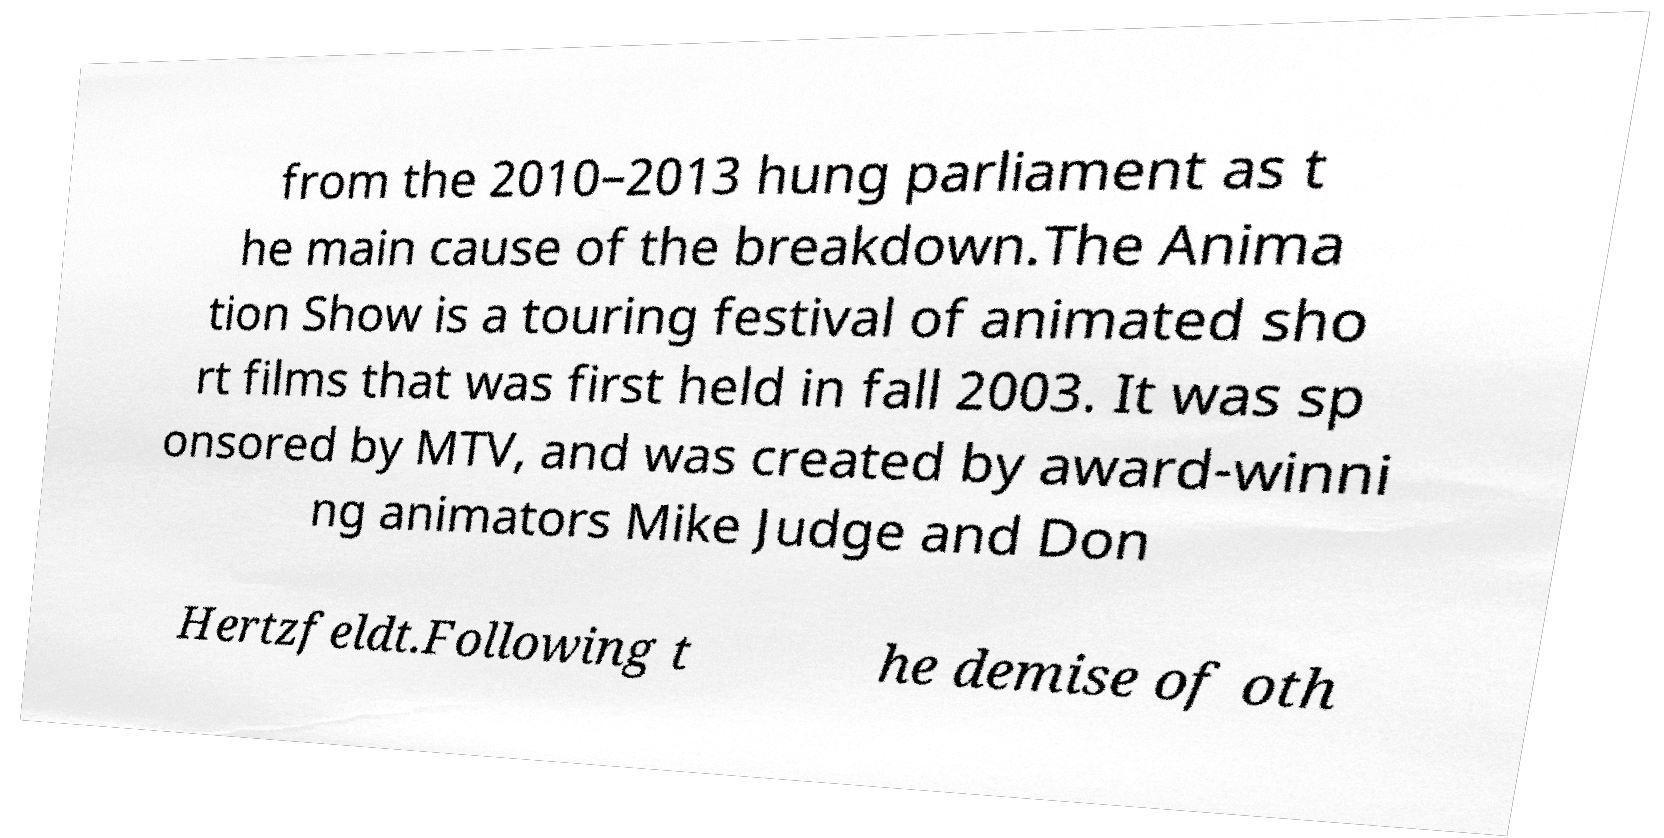Can you read and provide the text displayed in the image?This photo seems to have some interesting text. Can you extract and type it out for me? from the 2010–2013 hung parliament as t he main cause of the breakdown.The Anima tion Show is a touring festival of animated sho rt films that was first held in fall 2003. It was sp onsored by MTV, and was created by award-winni ng animators Mike Judge and Don Hertzfeldt.Following t he demise of oth 